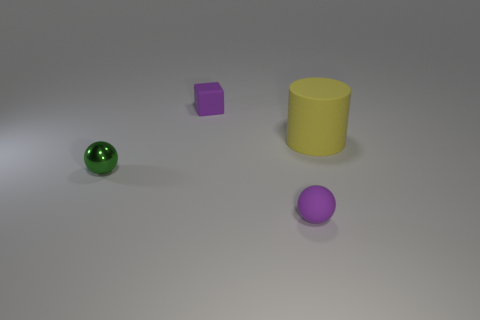There is a yellow object that is made of the same material as the tiny purple block; what is its shape?
Make the answer very short. Cylinder. What number of other things are the same shape as the green object?
Provide a succinct answer. 1. There is a small purple matte thing behind the rubber thing that is on the right side of the matte thing that is in front of the small shiny sphere; what shape is it?
Provide a short and direct response. Cube. How many blocks are big rubber things or small metal objects?
Keep it short and to the point. 0. Is there a tiny green metallic thing behind the purple rubber thing that is in front of the large yellow cylinder?
Provide a succinct answer. Yes. Are there any other things that have the same material as the green object?
Give a very brief answer. No. There is a green object; does it have the same shape as the purple rubber thing in front of the green metallic object?
Provide a short and direct response. Yes. What number of other things are the same size as the green metallic ball?
Make the answer very short. 2. How many blue objects are tiny blocks or small shiny balls?
Keep it short and to the point. 0. What number of small things are on the right side of the green ball and in front of the large yellow thing?
Make the answer very short. 1. 